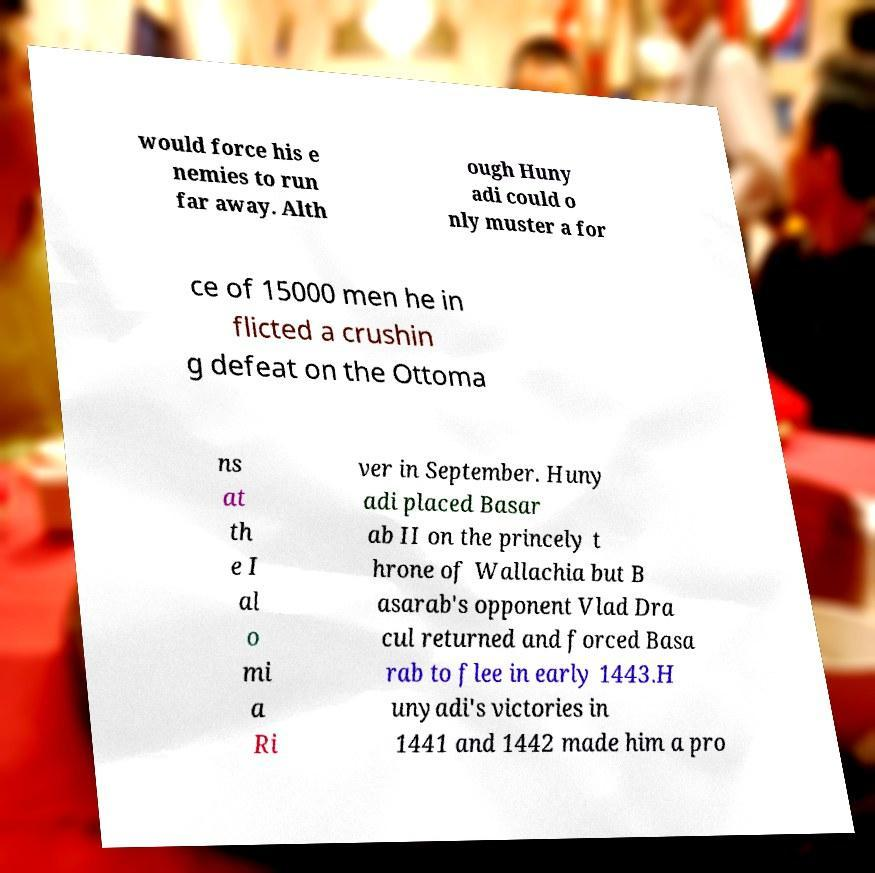For documentation purposes, I need the text within this image transcribed. Could you provide that? would force his e nemies to run far away. Alth ough Huny adi could o nly muster a for ce of 15000 men he in flicted a crushin g defeat on the Ottoma ns at th e I al o mi a Ri ver in September. Huny adi placed Basar ab II on the princely t hrone of Wallachia but B asarab's opponent Vlad Dra cul returned and forced Basa rab to flee in early 1443.H unyadi's victories in 1441 and 1442 made him a pro 